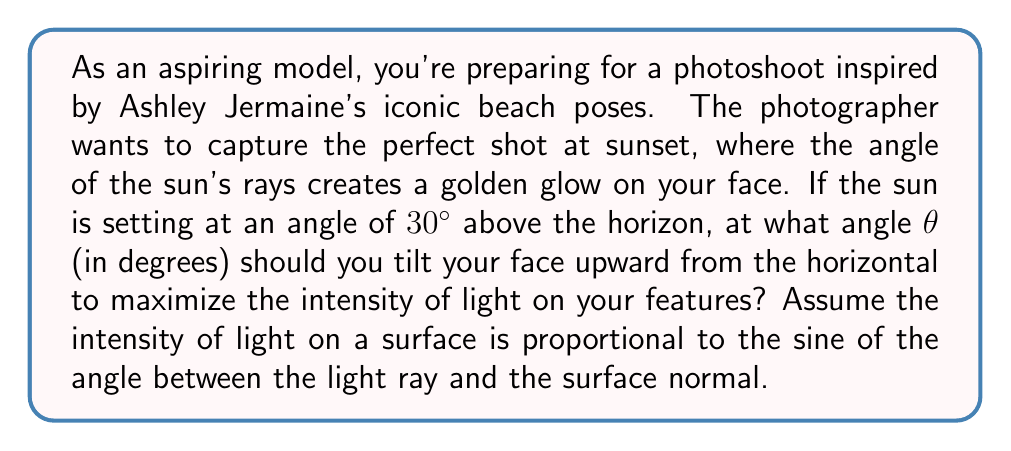Teach me how to tackle this problem. Let's approach this step-by-step:

1) The intensity of light on a surface is proportional to $\sin \alpha$, where $\alpha$ is the angle between the light ray and the surface normal.

2) In this case, we need to maximize $\sin \alpha$ to get the maximum intensity.

3) Let's visualize the scenario:

   [asy]
   import geometry;
   
   size(200);
   
   pair O=(0,0);
   pair A=(100,0);
   pair B=(100,57.7);
   pair C=(100,100);
   
   draw(O--A--C--O);
   draw(A--B,dashed);
   draw(B--C,Arrow);
   
   label("Horizon",(-10,0),W);
   label("Face normal",B,E);
   label("Sun ray",C,E);
   label("$30°$",(95,20));
   label("$\theta$",(10,10));
   label("$\alpha$",(95,70));
   
   markangle(A,O,B,radius=20);
   markangle(B,A,C,radius=20);
   [/asy]

4) From the diagram, we can see that:
   $$\alpha + \theta = 90° - 30° = 60°$$

5) We need to maximize $\sin \alpha$. In the range $[0°, 90°]$, $\sin \alpha$ is maximum when $\alpha = 90°$.

6) However, $\alpha$ is constrained by the equation in step 4. The maximum value it can take is 60°.

7) Therefore, to maximize the light intensity, we should have:
   $$\alpha = 60°$$

8) Substituting this back into the equation from step 4:
   $$60° + \theta = 60°$$
   $$\theta = 0°$$

Thus, you should keep your face parallel to the horizon (not tilted upward) to maximize the light intensity.
Answer: $0°$ 